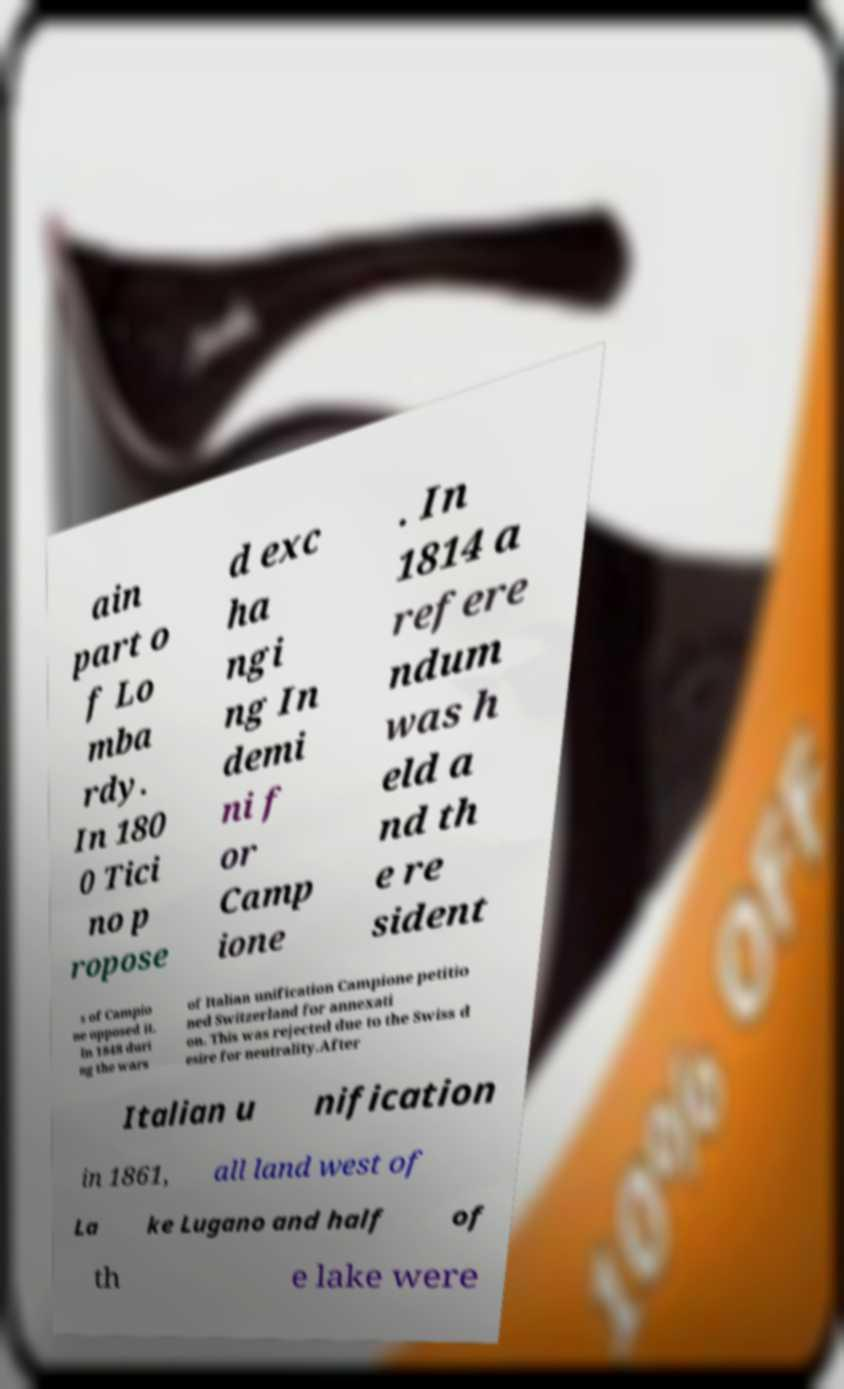Can you accurately transcribe the text from the provided image for me? ain part o f Lo mba rdy. In 180 0 Tici no p ropose d exc ha ngi ng In demi ni f or Camp ione . In 1814 a refere ndum was h eld a nd th e re sident s of Campio ne opposed it. In 1848 duri ng the wars of Italian unification Campione petitio ned Switzerland for annexati on. This was rejected due to the Swiss d esire for neutrality.After Italian u nification in 1861, all land west of La ke Lugano and half of th e lake were 